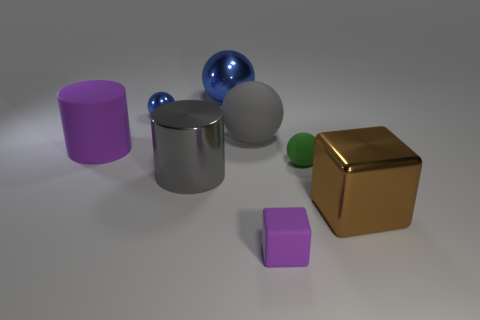There is a ball that is the same color as the small metallic object; what material is it?
Your answer should be compact. Metal. Do the gray cylinder and the green matte ball have the same size?
Provide a succinct answer. No. How many things are either big objects that are to the right of the matte cube or big objects?
Ensure brevity in your answer.  5. What is the shape of the large matte object behind the purple object behind the green matte object?
Make the answer very short. Sphere. Does the gray matte object have the same size as the object that is left of the tiny shiny sphere?
Provide a succinct answer. Yes. What is the material of the ball that is behind the small blue sphere?
Your answer should be very brief. Metal. What number of matte things are both right of the tiny blue thing and in front of the big rubber sphere?
Offer a terse response. 2. What material is the purple thing that is the same size as the gray rubber ball?
Your answer should be very brief. Rubber. There is a block behind the small purple cube; is it the same size as the blue object that is in front of the big blue shiny ball?
Provide a short and direct response. No. There is a tiny green rubber thing; are there any large cylinders behind it?
Your answer should be very brief. Yes. 